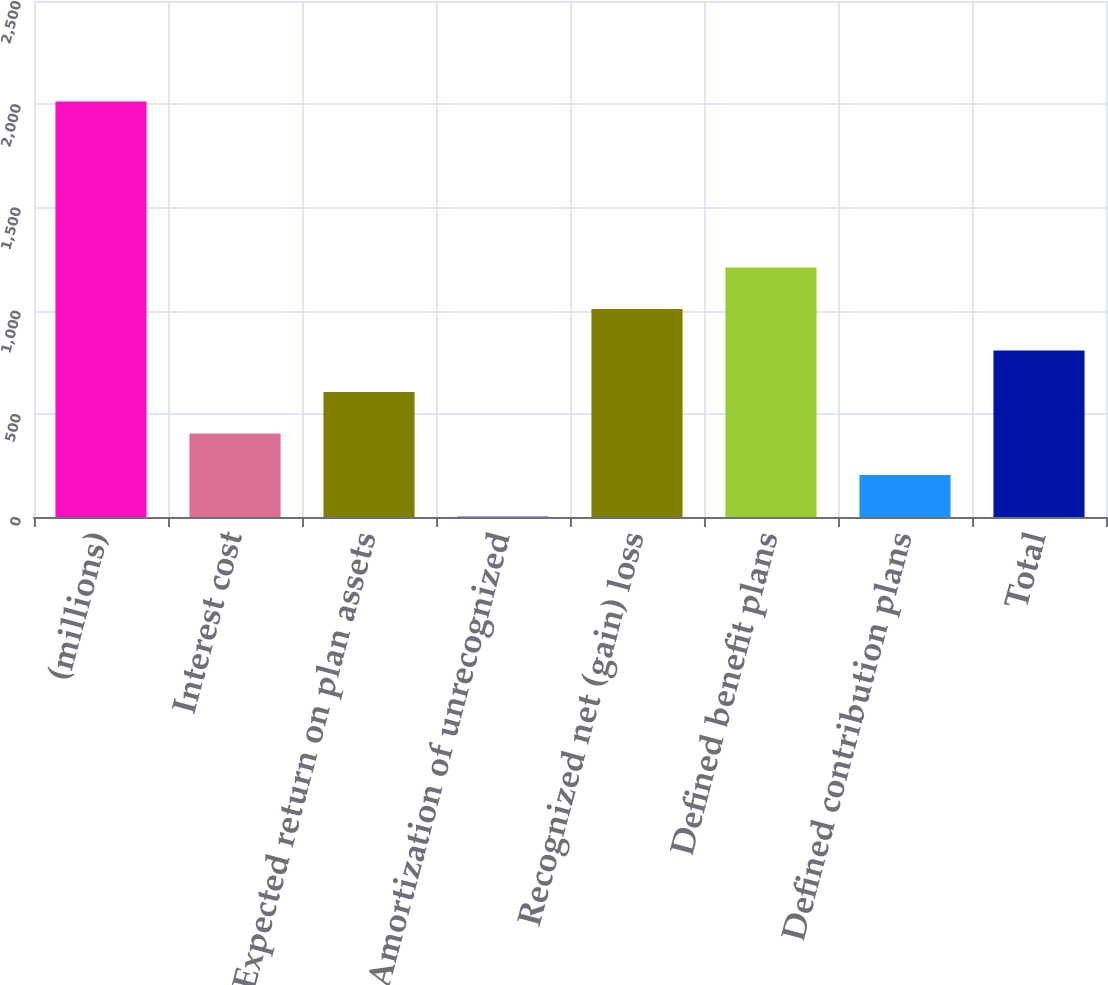Convert chart. <chart><loc_0><loc_0><loc_500><loc_500><bar_chart><fcel>(millions)<fcel>Interest cost<fcel>Expected return on plan assets<fcel>Amortization of unrecognized<fcel>Recognized net (gain) loss<fcel>Defined benefit plans<fcel>Defined contribution plans<fcel>Total<nl><fcel>2013<fcel>405<fcel>606<fcel>3<fcel>1008<fcel>1209<fcel>204<fcel>807<nl></chart> 